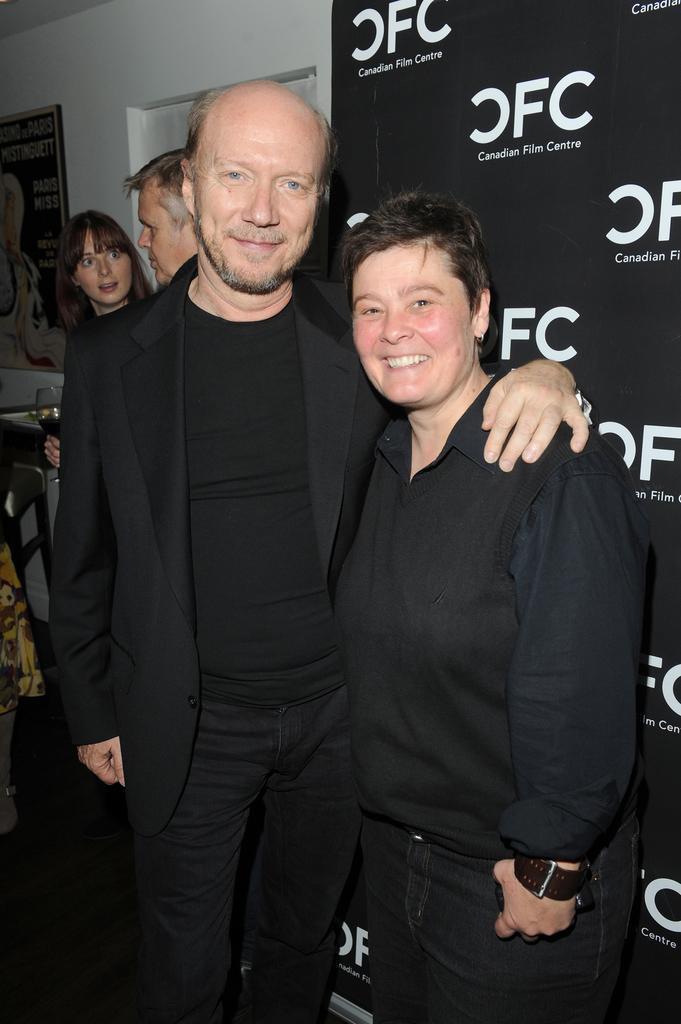Could you give a brief overview of what you see in this image? In this image there are two men and two women standing, the woman is holding a glass, the woman is holding an object, there is a board towards the right of the image, there is text on the board, there is a wall behind the persons, there are objects towards the left of the image, there is a photo frame on the wall, there is text on the photo frame, there is a roof towards the top of the image. 